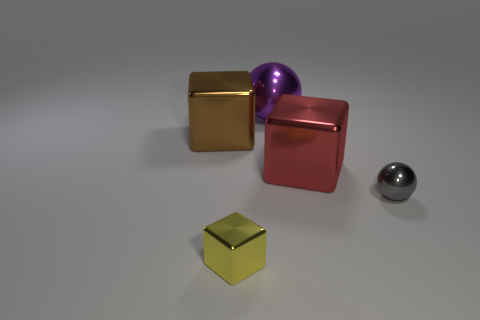Is the number of shiny blocks that are to the right of the large red metal thing less than the number of small yellow metallic blocks that are on the left side of the purple metallic sphere?
Your response must be concise. Yes. The tiny thing on the left side of the tiny gray ball has what shape?
Provide a short and direct response. Cube. Does the red thing have the same shape as the tiny object left of the large red object?
Offer a very short reply. Yes. What is the shape of the purple thing that is made of the same material as the big red thing?
Your answer should be compact. Sphere. Are there more large purple balls that are on the right side of the small metallic cube than yellow things that are behind the big red thing?
Give a very brief answer. Yes. How many things are metal cubes or small things?
Provide a succinct answer. 4. What number of other things are there of the same color as the big sphere?
Your answer should be very brief. 0. What is the shape of the gray object that is the same size as the yellow thing?
Make the answer very short. Sphere. There is a large metal thing that is in front of the brown block; what is its color?
Make the answer very short. Red. What number of objects are metal blocks in front of the brown thing or big things that are on the right side of the large brown shiny cube?
Keep it short and to the point. 3. 